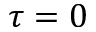Convert formula to latex. <formula><loc_0><loc_0><loc_500><loc_500>\tau = 0</formula> 